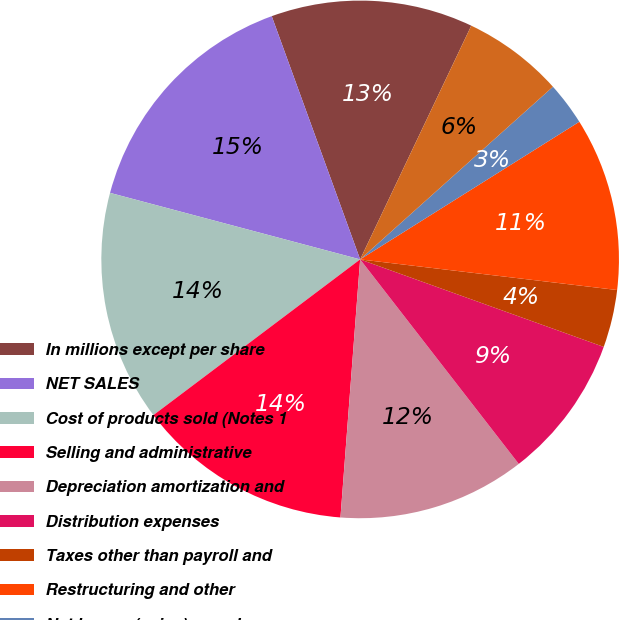<chart> <loc_0><loc_0><loc_500><loc_500><pie_chart><fcel>In millions except per share<fcel>NET SALES<fcel>Cost of products sold (Notes 1<fcel>Selling and administrative<fcel>Depreciation amortization and<fcel>Distribution expenses<fcel>Taxes other than payroll and<fcel>Restructuring and other<fcel>Net losses (gains) on sales<fcel>Interest expense net<nl><fcel>12.61%<fcel>15.31%<fcel>14.41%<fcel>13.51%<fcel>11.71%<fcel>9.01%<fcel>3.6%<fcel>10.81%<fcel>2.7%<fcel>6.31%<nl></chart> 